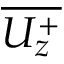<formula> <loc_0><loc_0><loc_500><loc_500>\overline { { U _ { z } ^ { + } } }</formula> 